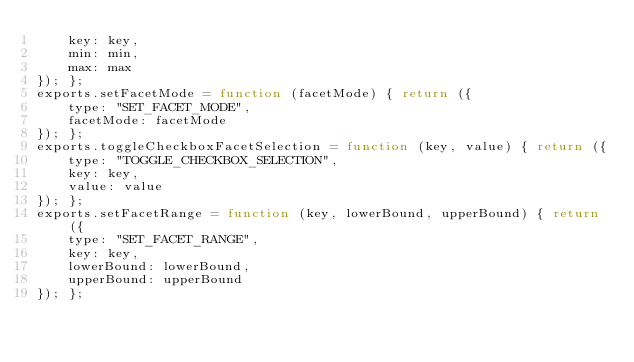Convert code to text. <code><loc_0><loc_0><loc_500><loc_500><_JavaScript_>    key: key,
    min: min,
    max: max
}); };
exports.setFacetMode = function (facetMode) { return ({
    type: "SET_FACET_MODE",
    facetMode: facetMode
}); };
exports.toggleCheckboxFacetSelection = function (key, value) { return ({
    type: "TOGGLE_CHECKBOX_SELECTION",
    key: key,
    value: value
}); };
exports.setFacetRange = function (key, lowerBound, upperBound) { return ({
    type: "SET_FACET_RANGE",
    key: key,
    lowerBound: lowerBound,
    upperBound: upperBound
}); };</code> 